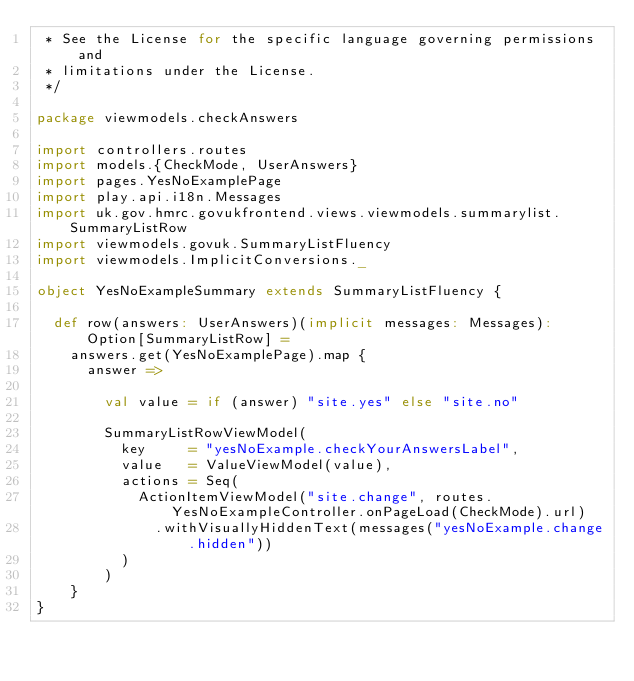Convert code to text. <code><loc_0><loc_0><loc_500><loc_500><_Scala_> * See the License for the specific language governing permissions and
 * limitations under the License.
 */

package viewmodels.checkAnswers

import controllers.routes
import models.{CheckMode, UserAnswers}
import pages.YesNoExamplePage
import play.api.i18n.Messages
import uk.gov.hmrc.govukfrontend.views.viewmodels.summarylist.SummaryListRow
import viewmodels.govuk.SummaryListFluency
import viewmodels.ImplicitConversions._

object YesNoExampleSummary extends SummaryListFluency {

  def row(answers: UserAnswers)(implicit messages: Messages): Option[SummaryListRow] =
    answers.get(YesNoExamplePage).map {
      answer =>

        val value = if (answer) "site.yes" else "site.no"

        SummaryListRowViewModel(
          key     = "yesNoExample.checkYourAnswersLabel",
          value   = ValueViewModel(value),
          actions = Seq(
            ActionItemViewModel("site.change", routes.YesNoExampleController.onPageLoad(CheckMode).url)
              .withVisuallyHiddenText(messages("yesNoExample.change.hidden"))
          )
        )
    }
}
</code> 